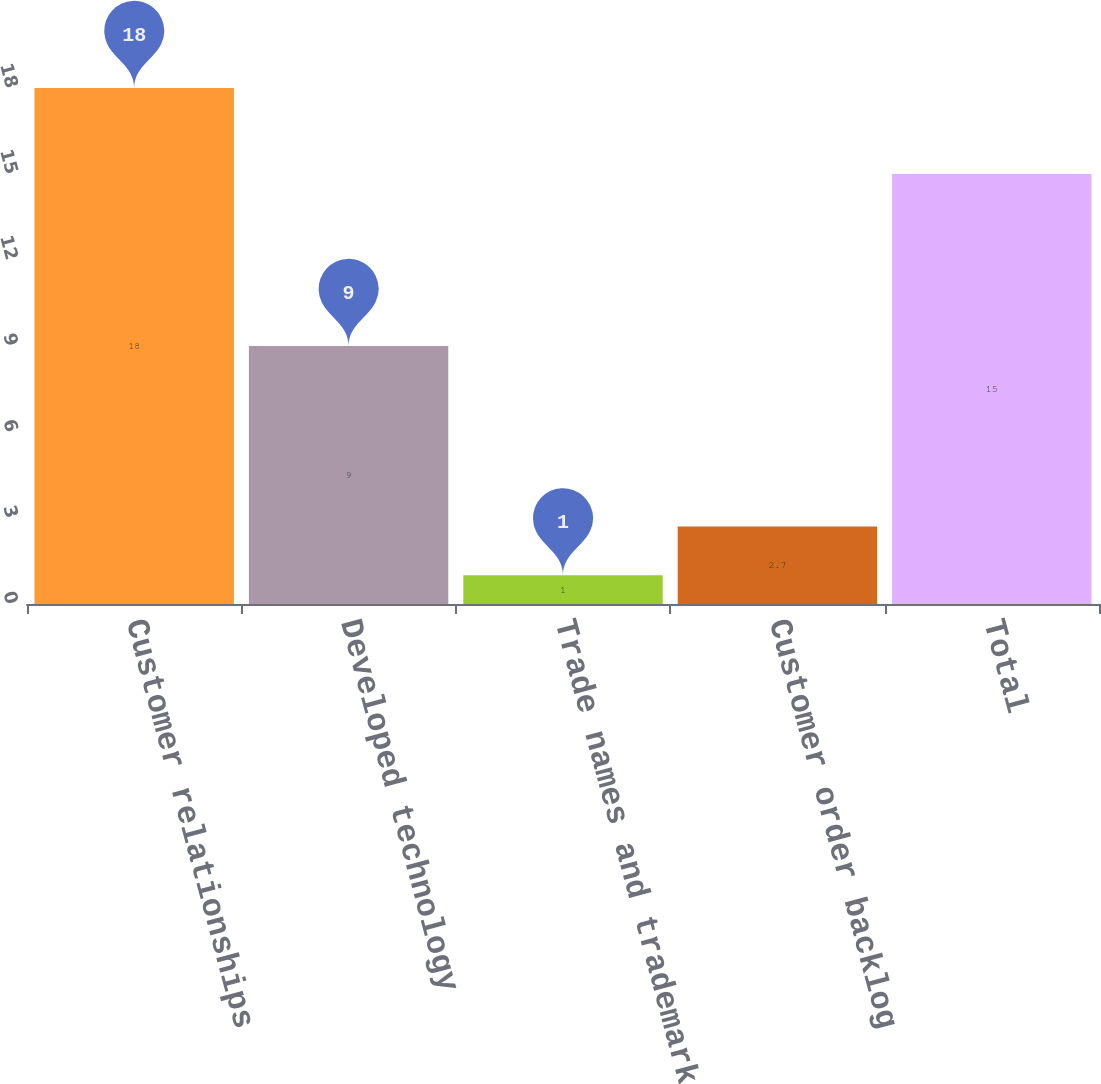Convert chart to OTSL. <chart><loc_0><loc_0><loc_500><loc_500><bar_chart><fcel>Customer relationships<fcel>Developed technology<fcel>Trade names and trademarks<fcel>Customer order backlog<fcel>Total<nl><fcel>18<fcel>9<fcel>1<fcel>2.7<fcel>15<nl></chart> 